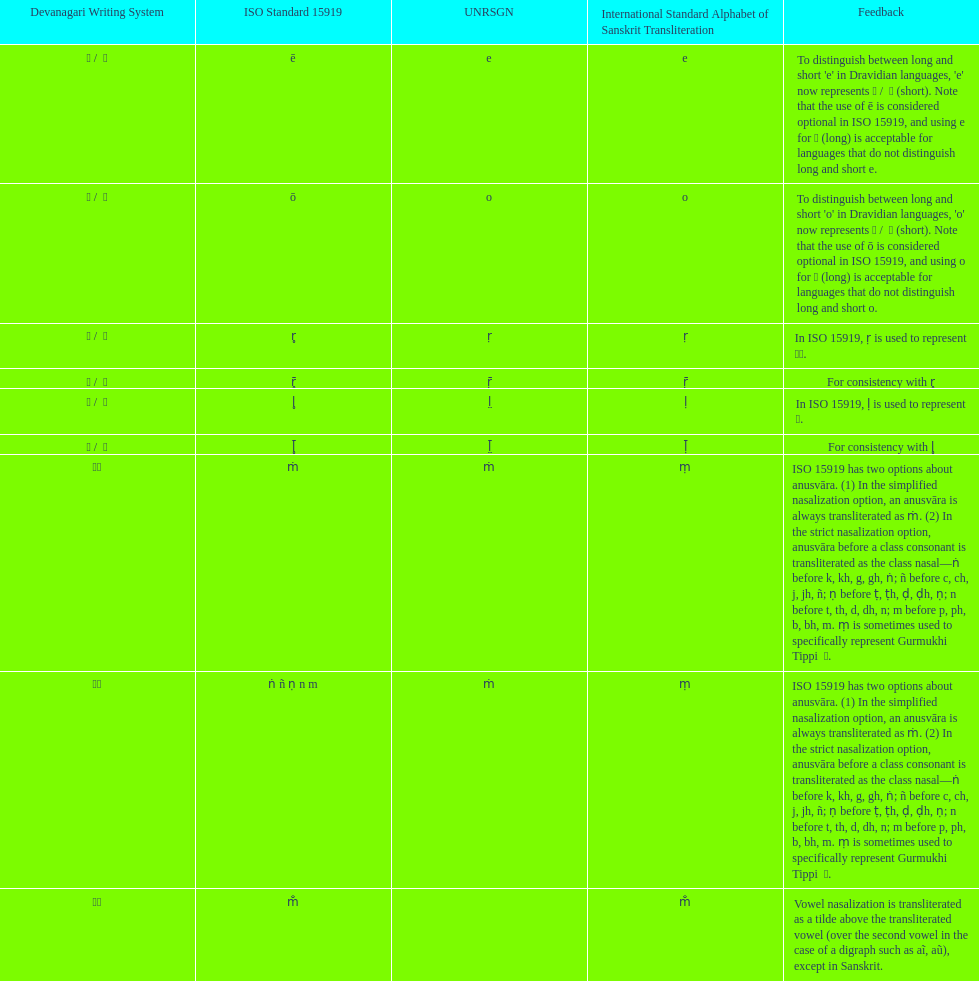This table shows the difference between how many transliterations? 3. 